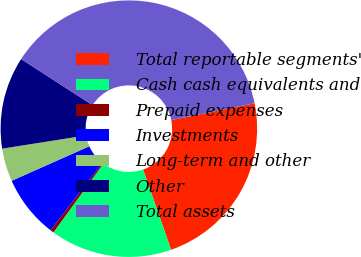Convert chart to OTSL. <chart><loc_0><loc_0><loc_500><loc_500><pie_chart><fcel>Total reportable segments'<fcel>Cash cash equivalents and<fcel>Prepaid expenses<fcel>Investments<fcel>Long-term and other<fcel>Other<fcel>Total assets<nl><fcel>22.84%<fcel>15.34%<fcel>0.44%<fcel>7.89%<fcel>4.17%<fcel>11.62%<fcel>37.69%<nl></chart> 